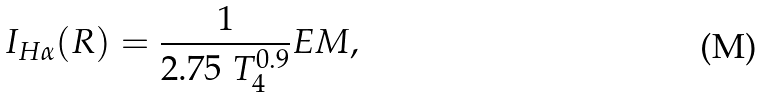Convert formula to latex. <formula><loc_0><loc_0><loc_500><loc_500>I _ { H \alpha } ( R ) = \frac { 1 } { 2 . 7 5 \ T _ { 4 } ^ { 0 . 9 } } E M ,</formula> 